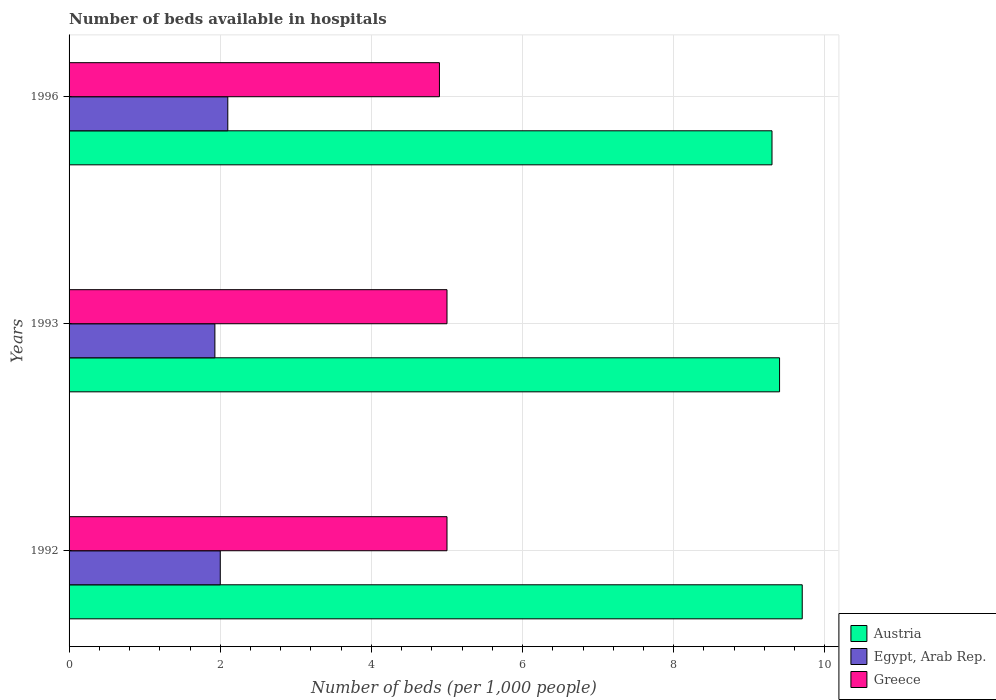What is the label of the 2nd group of bars from the top?
Keep it short and to the point. 1993. In how many cases, is the number of bars for a given year not equal to the number of legend labels?
Make the answer very short. 0. What is the number of beds in the hospiatls of in Egypt, Arab Rep. in 1996?
Keep it short and to the point. 2.1. Across all years, what is the maximum number of beds in the hospiatls of in Austria?
Provide a short and direct response. 9.7. Across all years, what is the minimum number of beds in the hospiatls of in Egypt, Arab Rep.?
Give a very brief answer. 1.93. What is the total number of beds in the hospiatls of in Greece in the graph?
Give a very brief answer. 14.9. What is the difference between the number of beds in the hospiatls of in Greece in 1993 and that in 1996?
Provide a succinct answer. 0.1. What is the difference between the number of beds in the hospiatls of in Egypt, Arab Rep. in 1993 and the number of beds in the hospiatls of in Greece in 1996?
Your answer should be very brief. -2.97. What is the average number of beds in the hospiatls of in Austria per year?
Your response must be concise. 9.47. In the year 1992, what is the difference between the number of beds in the hospiatls of in Greece and number of beds in the hospiatls of in Egypt, Arab Rep.?
Give a very brief answer. 3. What is the ratio of the number of beds in the hospiatls of in Austria in 1992 to that in 1996?
Make the answer very short. 1.04. Is the difference between the number of beds in the hospiatls of in Greece in 1992 and 1993 greater than the difference between the number of beds in the hospiatls of in Egypt, Arab Rep. in 1992 and 1993?
Your answer should be very brief. No. What is the difference between the highest and the second highest number of beds in the hospiatls of in Austria?
Provide a short and direct response. 0.3. What is the difference between the highest and the lowest number of beds in the hospiatls of in Austria?
Give a very brief answer. 0.4. In how many years, is the number of beds in the hospiatls of in Greece greater than the average number of beds in the hospiatls of in Greece taken over all years?
Give a very brief answer. 2. Is the sum of the number of beds in the hospiatls of in Egypt, Arab Rep. in 1992 and 1993 greater than the maximum number of beds in the hospiatls of in Greece across all years?
Make the answer very short. No. What does the 1st bar from the top in 1996 represents?
Make the answer very short. Greece. Are all the bars in the graph horizontal?
Ensure brevity in your answer.  Yes. How many years are there in the graph?
Provide a short and direct response. 3. Does the graph contain any zero values?
Ensure brevity in your answer.  No. Does the graph contain grids?
Your answer should be compact. Yes. Where does the legend appear in the graph?
Provide a succinct answer. Bottom right. How many legend labels are there?
Your answer should be compact. 3. How are the legend labels stacked?
Your answer should be very brief. Vertical. What is the title of the graph?
Keep it short and to the point. Number of beds available in hospitals. What is the label or title of the X-axis?
Ensure brevity in your answer.  Number of beds (per 1,0 people). What is the Number of beds (per 1,000 people) of Austria in 1992?
Provide a succinct answer. 9.7. What is the Number of beds (per 1,000 people) of Egypt, Arab Rep. in 1992?
Ensure brevity in your answer.  2. What is the Number of beds (per 1,000 people) of Austria in 1993?
Your answer should be compact. 9.4. What is the Number of beds (per 1,000 people) in Egypt, Arab Rep. in 1993?
Your answer should be very brief. 1.93. What is the Number of beds (per 1,000 people) of Austria in 1996?
Provide a short and direct response. 9.3. What is the Number of beds (per 1,000 people) of Egypt, Arab Rep. in 1996?
Offer a terse response. 2.1. What is the Number of beds (per 1,000 people) in Greece in 1996?
Give a very brief answer. 4.9. Across all years, what is the maximum Number of beds (per 1,000 people) in Austria?
Make the answer very short. 9.7. Across all years, what is the maximum Number of beds (per 1,000 people) in Egypt, Arab Rep.?
Ensure brevity in your answer.  2.1. Across all years, what is the maximum Number of beds (per 1,000 people) of Greece?
Ensure brevity in your answer.  5. Across all years, what is the minimum Number of beds (per 1,000 people) of Austria?
Your answer should be very brief. 9.3. Across all years, what is the minimum Number of beds (per 1,000 people) in Egypt, Arab Rep.?
Your answer should be very brief. 1.93. Across all years, what is the minimum Number of beds (per 1,000 people) in Greece?
Your response must be concise. 4.9. What is the total Number of beds (per 1,000 people) of Austria in the graph?
Provide a succinct answer. 28.4. What is the total Number of beds (per 1,000 people) in Egypt, Arab Rep. in the graph?
Ensure brevity in your answer.  6.03. What is the difference between the Number of beds (per 1,000 people) of Egypt, Arab Rep. in 1992 and that in 1993?
Provide a short and direct response. 0.07. What is the difference between the Number of beds (per 1,000 people) in Greece in 1992 and that in 1993?
Make the answer very short. 0. What is the difference between the Number of beds (per 1,000 people) of Egypt, Arab Rep. in 1992 and that in 1996?
Offer a very short reply. -0.1. What is the difference between the Number of beds (per 1,000 people) of Greece in 1992 and that in 1996?
Ensure brevity in your answer.  0.1. What is the difference between the Number of beds (per 1,000 people) in Egypt, Arab Rep. in 1993 and that in 1996?
Your response must be concise. -0.17. What is the difference between the Number of beds (per 1,000 people) in Austria in 1992 and the Number of beds (per 1,000 people) in Egypt, Arab Rep. in 1993?
Give a very brief answer. 7.77. What is the difference between the Number of beds (per 1,000 people) in Egypt, Arab Rep. in 1992 and the Number of beds (per 1,000 people) in Greece in 1993?
Give a very brief answer. -3. What is the difference between the Number of beds (per 1,000 people) in Egypt, Arab Rep. in 1992 and the Number of beds (per 1,000 people) in Greece in 1996?
Give a very brief answer. -2.9. What is the difference between the Number of beds (per 1,000 people) in Egypt, Arab Rep. in 1993 and the Number of beds (per 1,000 people) in Greece in 1996?
Your answer should be very brief. -2.97. What is the average Number of beds (per 1,000 people) of Austria per year?
Your response must be concise. 9.47. What is the average Number of beds (per 1,000 people) of Egypt, Arab Rep. per year?
Offer a terse response. 2.01. What is the average Number of beds (per 1,000 people) in Greece per year?
Your answer should be compact. 4.97. In the year 1992, what is the difference between the Number of beds (per 1,000 people) in Austria and Number of beds (per 1,000 people) in Egypt, Arab Rep.?
Make the answer very short. 7.7. In the year 1992, what is the difference between the Number of beds (per 1,000 people) of Austria and Number of beds (per 1,000 people) of Greece?
Keep it short and to the point. 4.7. In the year 1992, what is the difference between the Number of beds (per 1,000 people) in Egypt, Arab Rep. and Number of beds (per 1,000 people) in Greece?
Your answer should be very brief. -3. In the year 1993, what is the difference between the Number of beds (per 1,000 people) in Austria and Number of beds (per 1,000 people) in Egypt, Arab Rep.?
Your answer should be very brief. 7.47. In the year 1993, what is the difference between the Number of beds (per 1,000 people) of Egypt, Arab Rep. and Number of beds (per 1,000 people) of Greece?
Offer a terse response. -3.07. What is the ratio of the Number of beds (per 1,000 people) of Austria in 1992 to that in 1993?
Offer a terse response. 1.03. What is the ratio of the Number of beds (per 1,000 people) in Egypt, Arab Rep. in 1992 to that in 1993?
Offer a terse response. 1.04. What is the ratio of the Number of beds (per 1,000 people) in Greece in 1992 to that in 1993?
Provide a short and direct response. 1. What is the ratio of the Number of beds (per 1,000 people) in Austria in 1992 to that in 1996?
Make the answer very short. 1.04. What is the ratio of the Number of beds (per 1,000 people) in Egypt, Arab Rep. in 1992 to that in 1996?
Offer a terse response. 0.95. What is the ratio of the Number of beds (per 1,000 people) of Greece in 1992 to that in 1996?
Offer a terse response. 1.02. What is the ratio of the Number of beds (per 1,000 people) in Austria in 1993 to that in 1996?
Your answer should be compact. 1.01. What is the ratio of the Number of beds (per 1,000 people) of Egypt, Arab Rep. in 1993 to that in 1996?
Offer a very short reply. 0.92. What is the ratio of the Number of beds (per 1,000 people) of Greece in 1993 to that in 1996?
Offer a terse response. 1.02. What is the difference between the highest and the second highest Number of beds (per 1,000 people) of Egypt, Arab Rep.?
Provide a succinct answer. 0.1. What is the difference between the highest and the second highest Number of beds (per 1,000 people) in Greece?
Your answer should be very brief. 0. What is the difference between the highest and the lowest Number of beds (per 1,000 people) in Egypt, Arab Rep.?
Keep it short and to the point. 0.17. What is the difference between the highest and the lowest Number of beds (per 1,000 people) in Greece?
Make the answer very short. 0.1. 